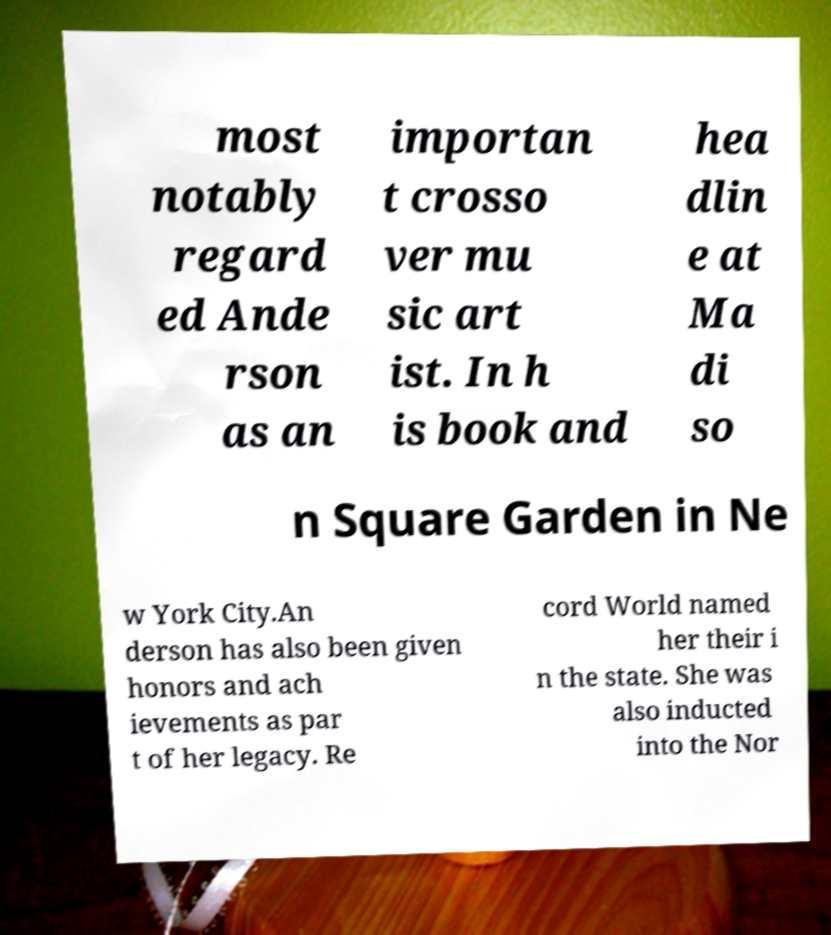There's text embedded in this image that I need extracted. Can you transcribe it verbatim? most notably regard ed Ande rson as an importan t crosso ver mu sic art ist. In h is book and hea dlin e at Ma di so n Square Garden in Ne w York City.An derson has also been given honors and ach ievements as par t of her legacy. Re cord World named her their i n the state. She was also inducted into the Nor 